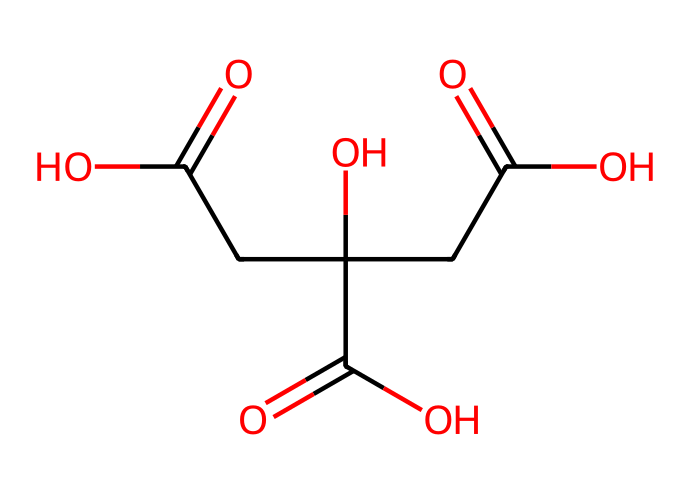What is the total number of carbon atoms in citric acid? By analyzing the SMILES representation, we count the carbon atoms present in the structure. In the representation, there are six distinct carbon atoms connected in various configurations.
Answer: six How many hydroxyl (OH) groups are present in citric acid? The SMILES representation indicates the presence of hydroxyl groups, which can be identified by the "O" atoms directly connected to a carbon atom (which also has a hydrogen). There are three -OH groups visible in the structure.
Answer: three Which functional group is prominent in citric acid? In the structure, the carboxylic acid functional group (-COOH) is evident due to the presence of carbonyl (C=O) and hydroxyl (OH) groups. There are three carboxylic acid groups identified.
Answer: carboxylic acid What is the degree of acidity of citric acid compared to common acids? Citric acid is a weak acid with a pKa value typically around 3.1 to 3.4 for its three acidic protons, indicating that it is more acidic than substances like vinegar (acetic acid) but less acidic than strong acids like hydrochloric acid.
Answer: weak acid How many double bonds are present in the citric acid structure? To identify double bonds, we look for instances of "C=O" in the SMILES. There are three carbonyl (C=O) groups, indicating three double bonds in citric acid.
Answer: three What is the effect of the carboxylic acid groups on the flavor profile of pastries? Carboxylic acid groups are known to contribute acidity and tartness, which enhances flavor complexity in food. Specifically, in citric acid, this sourness is beneficial in balancing sweetness in fruit-flavored pastries.
Answer: tartness 